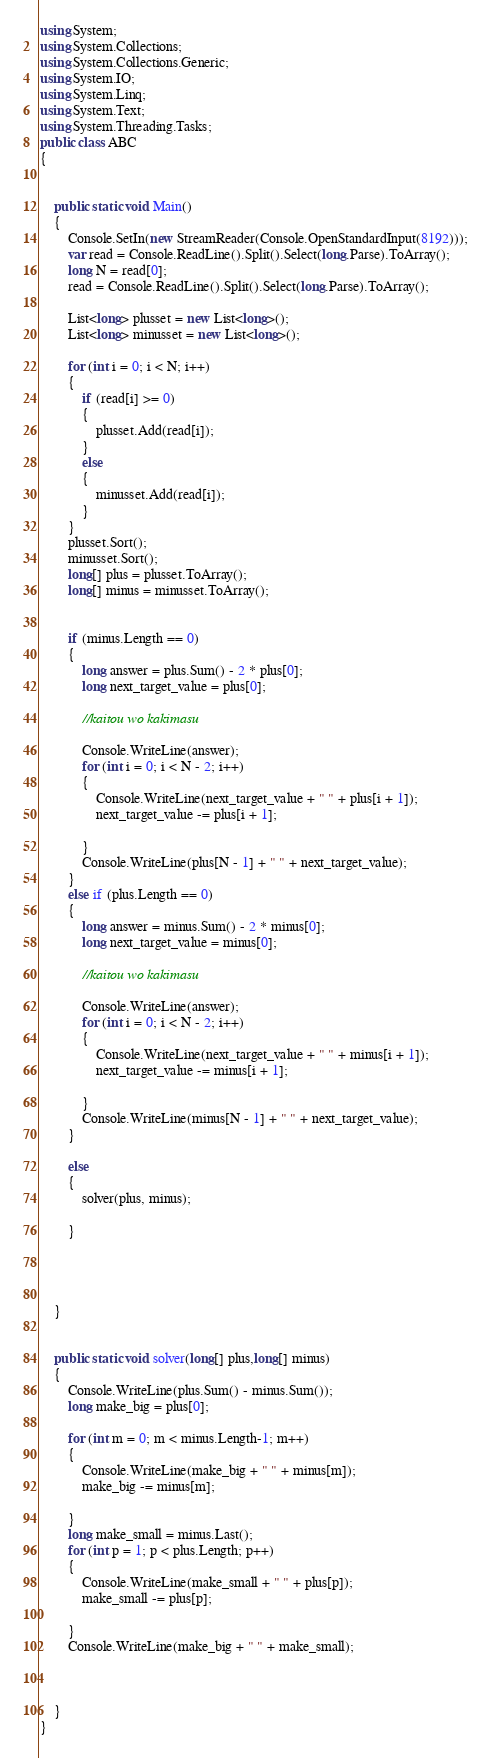Convert code to text. <code><loc_0><loc_0><loc_500><loc_500><_C#_>using System;
using System.Collections;
using System.Collections.Generic;
using System.IO;
using System.Linq;
using System.Text;
using System.Threading.Tasks;
public class ABC
{


    public static void Main()
    {
        Console.SetIn(new StreamReader(Console.OpenStandardInput(8192)));
        var read = Console.ReadLine().Split().Select(long.Parse).ToArray();
        long N = read[0];
        read = Console.ReadLine().Split().Select(long.Parse).ToArray();

        List<long> plusset = new List<long>();
        List<long> minusset = new List<long>();

        for (int i = 0; i < N; i++)
        {
            if (read[i] >= 0)
            {
                plusset.Add(read[i]);
            }
            else
            {
                minusset.Add(read[i]);
            }
        }
        plusset.Sort();
        minusset.Sort();
        long[] plus = plusset.ToArray();
        long[] minus = minusset.ToArray(); 


        if (minus.Length == 0)
        {
            long answer = plus.Sum() - 2 * plus[0];
            long next_target_value = plus[0];

            //kaitou wo kakimasu

            Console.WriteLine(answer);
            for (int i = 0; i < N - 2; i++)
            {
                Console.WriteLine(next_target_value + " " + plus[i + 1]);
                next_target_value -= plus[i + 1];

            }
            Console.WriteLine(plus[N - 1] + " " + next_target_value);
        }
        else if (plus.Length == 0)
        {
            long answer = minus.Sum() - 2 * minus[0];
            long next_target_value = minus[0];

            //kaitou wo kakimasu

            Console.WriteLine(answer);
            for (int i = 0; i < N - 2; i++)
            {
                Console.WriteLine(next_target_value + " " + minus[i + 1]);
                next_target_value -= minus[i + 1];

            }
            Console.WriteLine(minus[N - 1] + " " + next_target_value);
        }

        else
        {
            solver(plus, minus);

        }




    }


    public static void solver(long[] plus,long[] minus)
    {
        Console.WriteLine(plus.Sum() - minus.Sum());
        long make_big = plus[0];

        for (int m = 0; m < minus.Length-1; m++)
        {
            Console.WriteLine(make_big + " " + minus[m]);
            make_big -= minus[m];

        }
        long make_small = minus.Last();
        for (int p = 1; p < plus.Length; p++)
        {
            Console.WriteLine(make_small + " " + plus[p]);
            make_small -= plus[p];

        }
        Console.WriteLine(make_big + " " + make_small);



    }
}</code> 